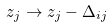<formula> <loc_0><loc_0><loc_500><loc_500>z _ { j } \rightarrow z _ { j } - \Delta _ { i j }</formula> 